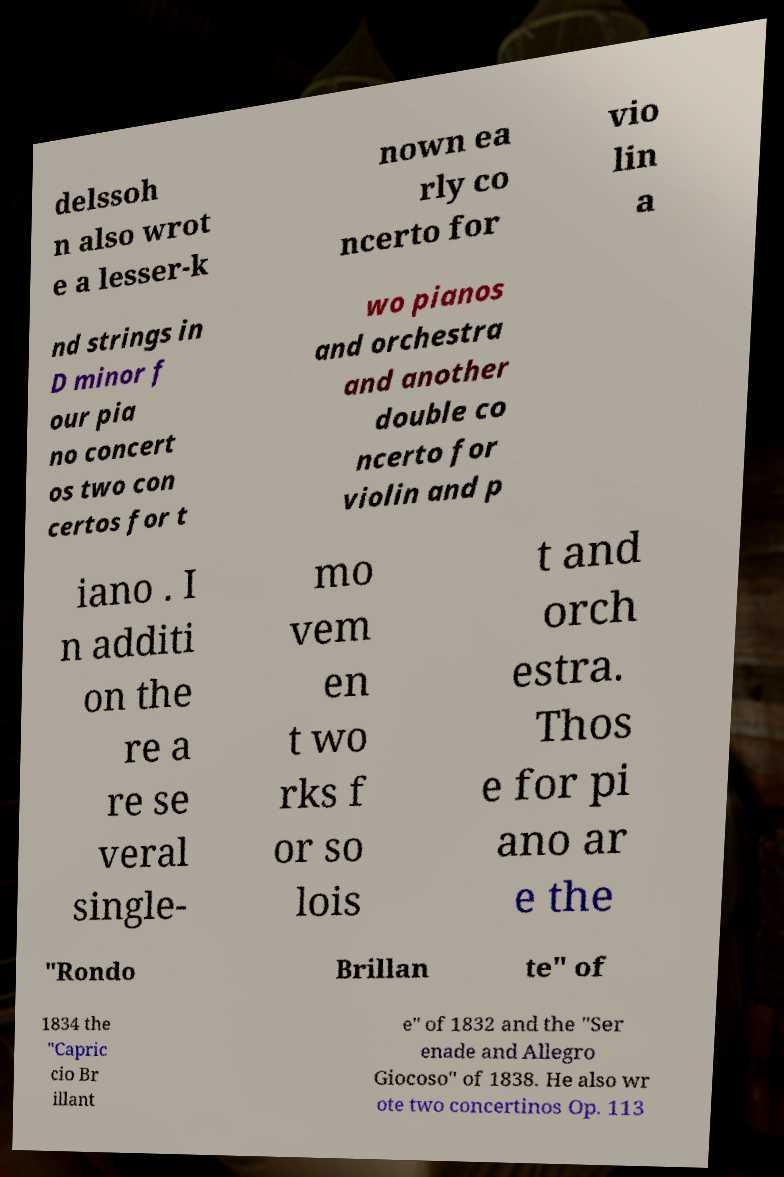What messages or text are displayed in this image? I need them in a readable, typed format. delssoh n also wrot e a lesser-k nown ea rly co ncerto for vio lin a nd strings in D minor f our pia no concert os two con certos for t wo pianos and orchestra and another double co ncerto for violin and p iano . I n additi on the re a re se veral single- mo vem en t wo rks f or so lois t and orch estra. Thos e for pi ano ar e the "Rondo Brillan te" of 1834 the "Capric cio Br illant e" of 1832 and the "Ser enade and Allegro Giocoso" of 1838. He also wr ote two concertinos Op. 113 